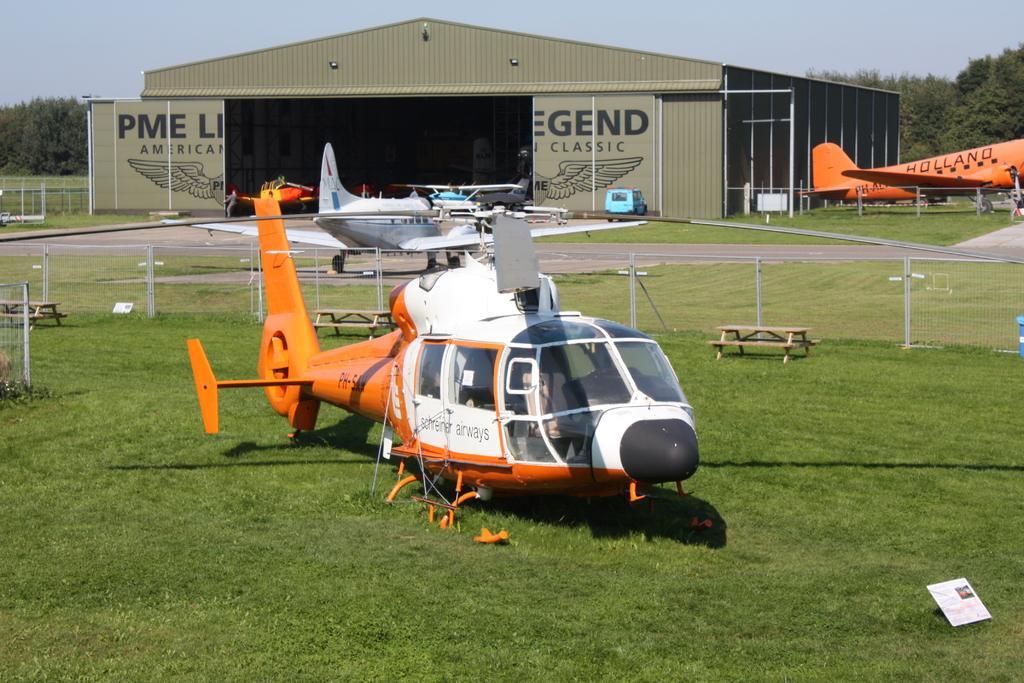How would you summarize this image in a sentence or two? In the foreground of the picture there is a helicopter. In the center of the picture there are benches, railing, grass, runway and aircraft. In the background there are trees, railing, grass, aircraft, vehicle, person and a building. Sky is sunny. 